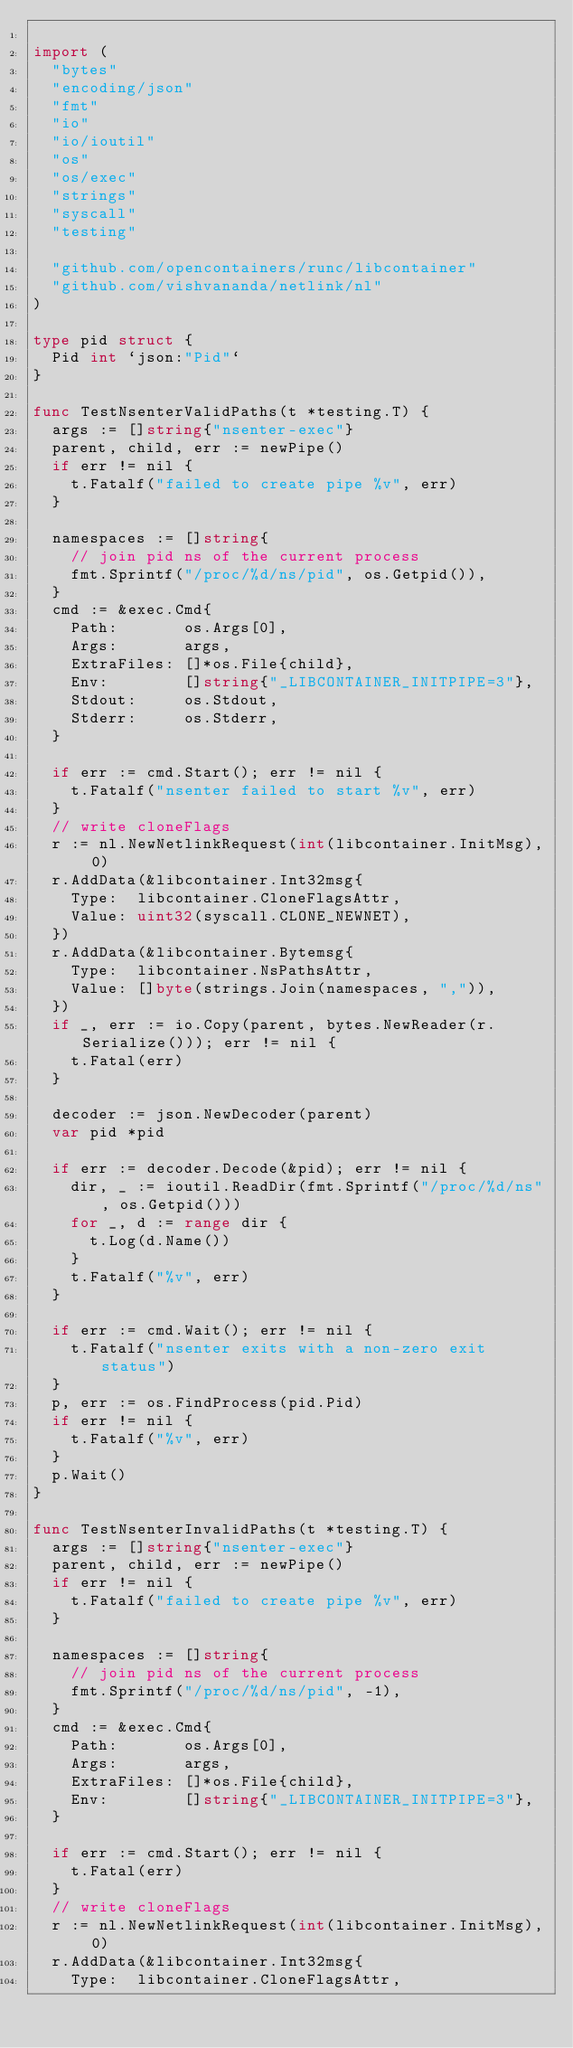Convert code to text. <code><loc_0><loc_0><loc_500><loc_500><_Go_>
import (
	"bytes"
	"encoding/json"
	"fmt"
	"io"
	"io/ioutil"
	"os"
	"os/exec"
	"strings"
	"syscall"
	"testing"

	"github.com/opencontainers/runc/libcontainer"
	"github.com/vishvananda/netlink/nl"
)

type pid struct {
	Pid int `json:"Pid"`
}

func TestNsenterValidPaths(t *testing.T) {
	args := []string{"nsenter-exec"}
	parent, child, err := newPipe()
	if err != nil {
		t.Fatalf("failed to create pipe %v", err)
	}

	namespaces := []string{
		// join pid ns of the current process
		fmt.Sprintf("/proc/%d/ns/pid", os.Getpid()),
	}
	cmd := &exec.Cmd{
		Path:       os.Args[0],
		Args:       args,
		ExtraFiles: []*os.File{child},
		Env:        []string{"_LIBCONTAINER_INITPIPE=3"},
		Stdout:     os.Stdout,
		Stderr:     os.Stderr,
	}

	if err := cmd.Start(); err != nil {
		t.Fatalf("nsenter failed to start %v", err)
	}
	// write cloneFlags
	r := nl.NewNetlinkRequest(int(libcontainer.InitMsg), 0)
	r.AddData(&libcontainer.Int32msg{
		Type:  libcontainer.CloneFlagsAttr,
		Value: uint32(syscall.CLONE_NEWNET),
	})
	r.AddData(&libcontainer.Bytemsg{
		Type:  libcontainer.NsPathsAttr,
		Value: []byte(strings.Join(namespaces, ",")),
	})
	if _, err := io.Copy(parent, bytes.NewReader(r.Serialize())); err != nil {
		t.Fatal(err)
	}

	decoder := json.NewDecoder(parent)
	var pid *pid

	if err := decoder.Decode(&pid); err != nil {
		dir, _ := ioutil.ReadDir(fmt.Sprintf("/proc/%d/ns", os.Getpid()))
		for _, d := range dir {
			t.Log(d.Name())
		}
		t.Fatalf("%v", err)
	}

	if err := cmd.Wait(); err != nil {
		t.Fatalf("nsenter exits with a non-zero exit status")
	}
	p, err := os.FindProcess(pid.Pid)
	if err != nil {
		t.Fatalf("%v", err)
	}
	p.Wait()
}

func TestNsenterInvalidPaths(t *testing.T) {
	args := []string{"nsenter-exec"}
	parent, child, err := newPipe()
	if err != nil {
		t.Fatalf("failed to create pipe %v", err)
	}

	namespaces := []string{
		// join pid ns of the current process
		fmt.Sprintf("/proc/%d/ns/pid", -1),
	}
	cmd := &exec.Cmd{
		Path:       os.Args[0],
		Args:       args,
		ExtraFiles: []*os.File{child},
		Env:        []string{"_LIBCONTAINER_INITPIPE=3"},
	}

	if err := cmd.Start(); err != nil {
		t.Fatal(err)
	}
	// write cloneFlags
	r := nl.NewNetlinkRequest(int(libcontainer.InitMsg), 0)
	r.AddData(&libcontainer.Int32msg{
		Type:  libcontainer.CloneFlagsAttr,</code> 